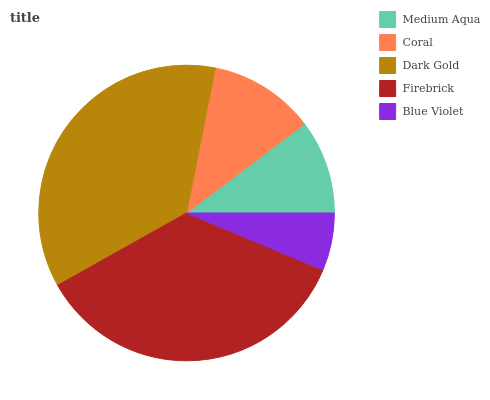Is Blue Violet the minimum?
Answer yes or no. Yes. Is Dark Gold the maximum?
Answer yes or no. Yes. Is Coral the minimum?
Answer yes or no. No. Is Coral the maximum?
Answer yes or no. No. Is Coral greater than Medium Aqua?
Answer yes or no. Yes. Is Medium Aqua less than Coral?
Answer yes or no. Yes. Is Medium Aqua greater than Coral?
Answer yes or no. No. Is Coral less than Medium Aqua?
Answer yes or no. No. Is Coral the high median?
Answer yes or no. Yes. Is Coral the low median?
Answer yes or no. Yes. Is Dark Gold the high median?
Answer yes or no. No. Is Blue Violet the low median?
Answer yes or no. No. 